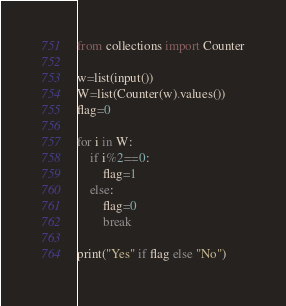<code> <loc_0><loc_0><loc_500><loc_500><_Python_>from collections import Counter

w=list(input())
W=list(Counter(w).values())
flag=0

for i in W:
    if i%2==0:
        flag=1
    else:
        flag=0
        break
        
print("Yes" if flag else "No")</code> 